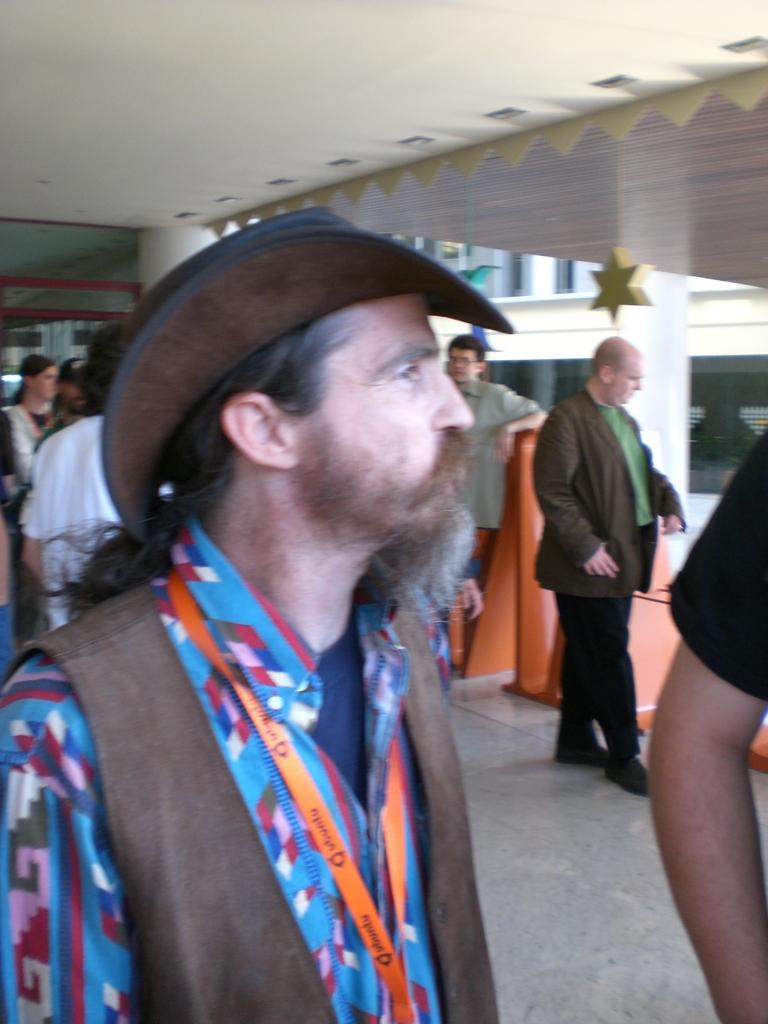What are the people in the image doing? There are persons standing and walking in the image. What can be seen in the background of the image? There is a building in the background of the image. What is the color of the object in the image? There is an object in the image that is red in color. Can you hear the people in the image laughing? There is no audio in the image, so it is not possible to hear the people laughing. What is the end result of the persons walking in the image? The image only shows the persons walking, so there is no indication of an end result. 